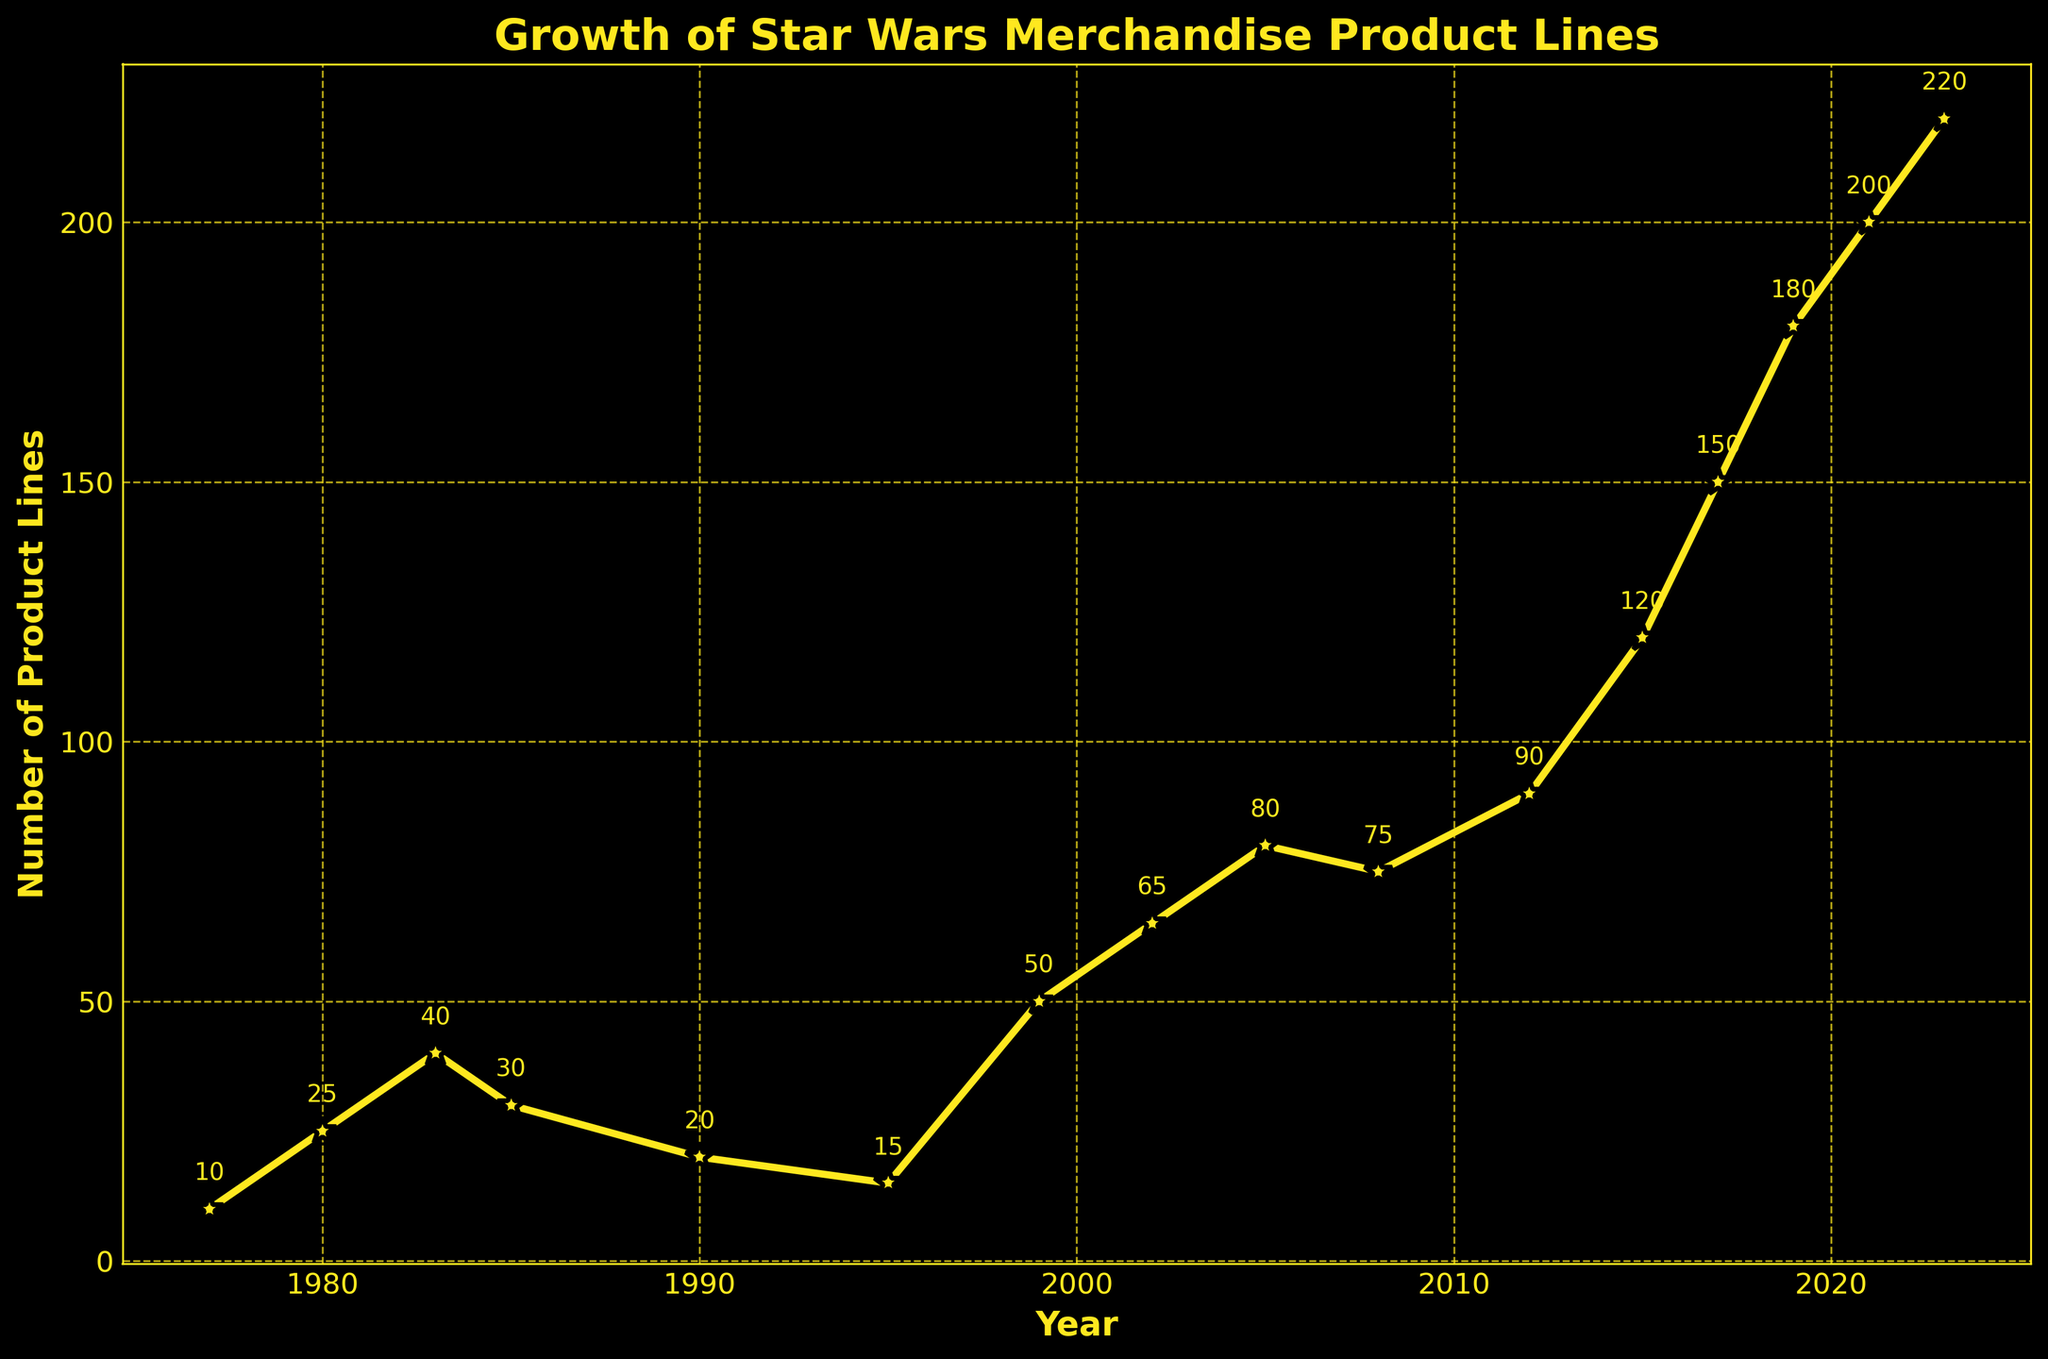When did the number of official Star Wars merchandise product lines first exceed 50? The number of product lines first exceeded 50 in 1999. Looking at the figure, the point for the year 1999 shows 50 product lines, and every subsequent year has a higher value.
Answer: 1999 What is the difference in the number of product lines between 1983 and 1995? The number of product lines in 1983 is 40 and in 1995 is 15. The difference is calculated by subtracting the 1995 value from the 1983 value: 40 - 15 = 25.
Answer: 25 Which year had the highest number of product lines, and what was the value? The year 2023 has the highest number of product lines at 220. This is observed as the highest point on the plot at year 2023.
Answer: 2023, 220 How many times did the number of product lines decrease from one recorded year to the next? The figure shows decreases occurring between 1983 (40) and 1985 (30), 1985 (30) and 1990 (20), and 2008 (75) and 2012 (90). Therefore, it decreased 3 times.
Answer: 3 What is the average number of product lines recorded in the years 1980, 1990, and 2000? The values for these years are 25 (1980), 20 (1990), and 65 (2000). To get the average, sum them up: 25 + 20 + 65 = 110, then divide by 3, which gives 110 / 3 ≈ 36.67.
Answer: 36.67 What was the number of product lines in 2021 compared to 2017? The number of product lines in 2021 was 200, and in 2017 it was 150. Comparing these values, 2021 had 50 more product lines than 2017.
Answer: 50 more in 2021 Between which consecutive years was the growth rate of product lines the highest? The largest increase in product lines can be found by examining the vertical differences between consecutive points. The biggest jump is from 2012 (90) to 2015 (120), an increase of 30.
Answer: Between 2012 and 2015 How many product lines did Star Wars have by 1980? By 1980, the figure shows 25 product lines.
Answer: 25 What's the median number of product lines over the entire timeline? To find the median, list all product line counts in order: 10, 15, 20, 25, 30, 40, 50, 65, 75, 80, 90, 120, 150, 180, 200, 220. There are 16 values, so the median is the average of the 8th and 9th values: (75 + 80) / 2 = 77.5.
Answer: 77.5 What visual features are used to highlight the data points? The data points in the figure are highlighted with star markers, marker edges in black, and a yellow color for lines and markers. This contrast makes the data stand out against the black background.
Answer: Star markers, black edges, yellow color 